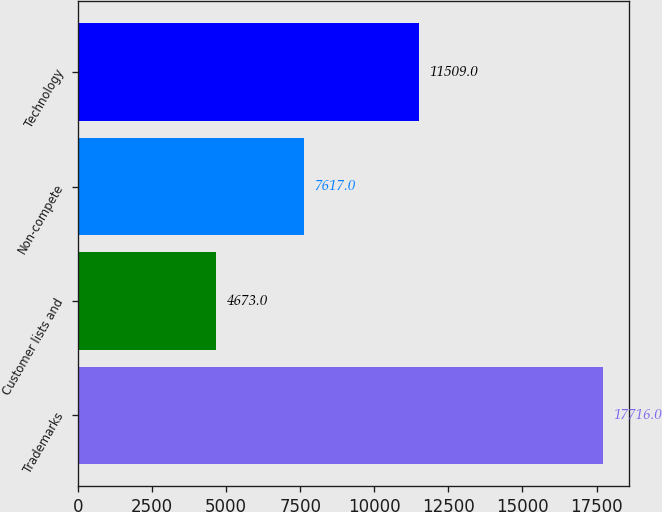Convert chart to OTSL. <chart><loc_0><loc_0><loc_500><loc_500><bar_chart><fcel>Trademarks<fcel>Customer lists and<fcel>Non-compete<fcel>Technology<nl><fcel>17716<fcel>4673<fcel>7617<fcel>11509<nl></chart> 